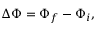Convert formula to latex. <formula><loc_0><loc_0><loc_500><loc_500>\Delta \Phi = \Phi _ { f } - \Phi _ { i } ,</formula> 